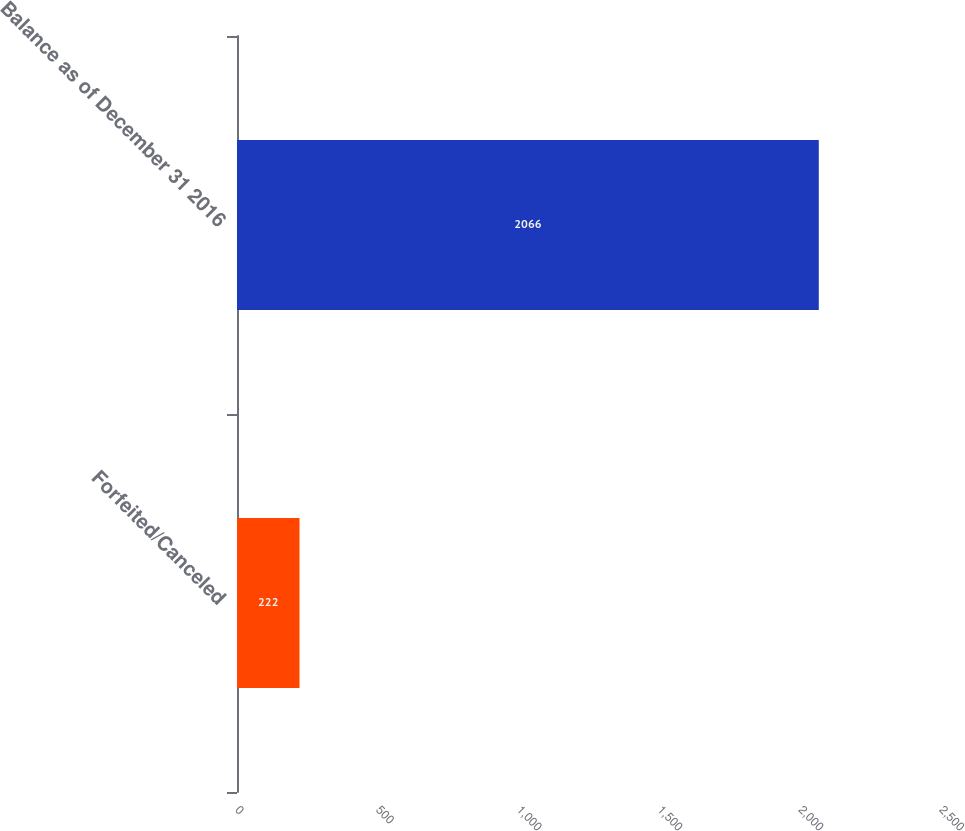Convert chart. <chart><loc_0><loc_0><loc_500><loc_500><bar_chart><fcel>Forfeited/Canceled<fcel>Balance as of December 31 2016<nl><fcel>222<fcel>2066<nl></chart> 